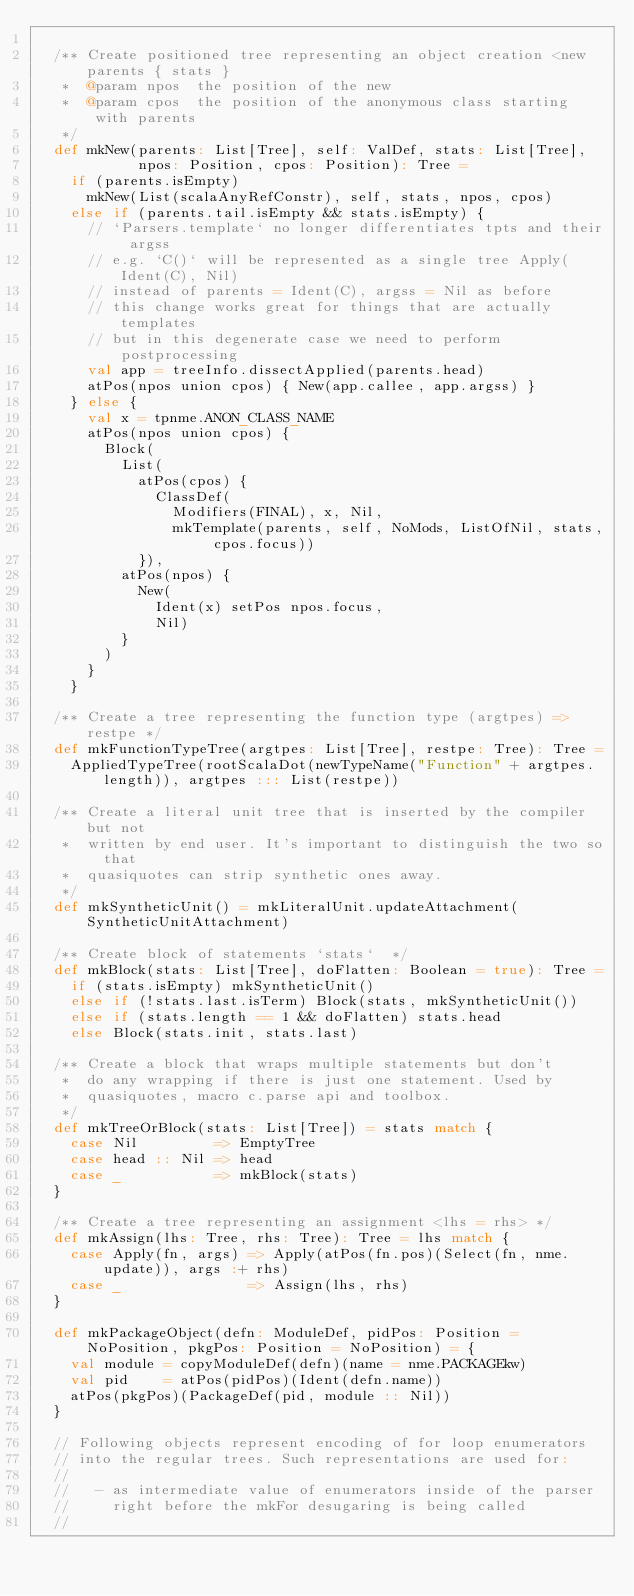Convert code to text. <code><loc_0><loc_0><loc_500><loc_500><_Scala_>
  /** Create positioned tree representing an object creation <new parents { stats }
   *  @param npos  the position of the new
   *  @param cpos  the position of the anonymous class starting with parents
   */
  def mkNew(parents: List[Tree], self: ValDef, stats: List[Tree],
            npos: Position, cpos: Position): Tree =
    if (parents.isEmpty)
      mkNew(List(scalaAnyRefConstr), self, stats, npos, cpos)
    else if (parents.tail.isEmpty && stats.isEmpty) {
      // `Parsers.template` no longer differentiates tpts and their argss
      // e.g. `C()` will be represented as a single tree Apply(Ident(C), Nil)
      // instead of parents = Ident(C), argss = Nil as before
      // this change works great for things that are actually templates
      // but in this degenerate case we need to perform postprocessing
      val app = treeInfo.dissectApplied(parents.head)
      atPos(npos union cpos) { New(app.callee, app.argss) }
    } else {
      val x = tpnme.ANON_CLASS_NAME
      atPos(npos union cpos) {
        Block(
          List(
            atPos(cpos) {
              ClassDef(
                Modifiers(FINAL), x, Nil,
                mkTemplate(parents, self, NoMods, ListOfNil, stats, cpos.focus))
            }),
          atPos(npos) {
            New(
              Ident(x) setPos npos.focus,
              Nil)
          }
        )
      }
    }

  /** Create a tree representing the function type (argtpes) => restpe */
  def mkFunctionTypeTree(argtpes: List[Tree], restpe: Tree): Tree =
    AppliedTypeTree(rootScalaDot(newTypeName("Function" + argtpes.length)), argtpes ::: List(restpe))

  /** Create a literal unit tree that is inserted by the compiler but not
   *  written by end user. It's important to distinguish the two so that
   *  quasiquotes can strip synthetic ones away.
   */
  def mkSyntheticUnit() = mkLiteralUnit.updateAttachment(SyntheticUnitAttachment)

  /** Create block of statements `stats`  */
  def mkBlock(stats: List[Tree], doFlatten: Boolean = true): Tree =
    if (stats.isEmpty) mkSyntheticUnit()
    else if (!stats.last.isTerm) Block(stats, mkSyntheticUnit())
    else if (stats.length == 1 && doFlatten) stats.head
    else Block(stats.init, stats.last)

  /** Create a block that wraps multiple statements but don't
   *  do any wrapping if there is just one statement. Used by
   *  quasiquotes, macro c.parse api and toolbox.
   */
  def mkTreeOrBlock(stats: List[Tree]) = stats match {
    case Nil         => EmptyTree
    case head :: Nil => head
    case _           => mkBlock(stats)
  }

  /** Create a tree representing an assignment <lhs = rhs> */
  def mkAssign(lhs: Tree, rhs: Tree): Tree = lhs match {
    case Apply(fn, args) => Apply(atPos(fn.pos)(Select(fn, nme.update)), args :+ rhs)
    case _               => Assign(lhs, rhs)
  }

  def mkPackageObject(defn: ModuleDef, pidPos: Position = NoPosition, pkgPos: Position = NoPosition) = {
    val module = copyModuleDef(defn)(name = nme.PACKAGEkw)
    val pid    = atPos(pidPos)(Ident(defn.name))
    atPos(pkgPos)(PackageDef(pid, module :: Nil))
  }

  // Following objects represent encoding of for loop enumerators
  // into the regular trees. Such representations are used for:
  //
  //   - as intermediate value of enumerators inside of the parser
  //     right before the mkFor desugaring is being called
  //</code> 